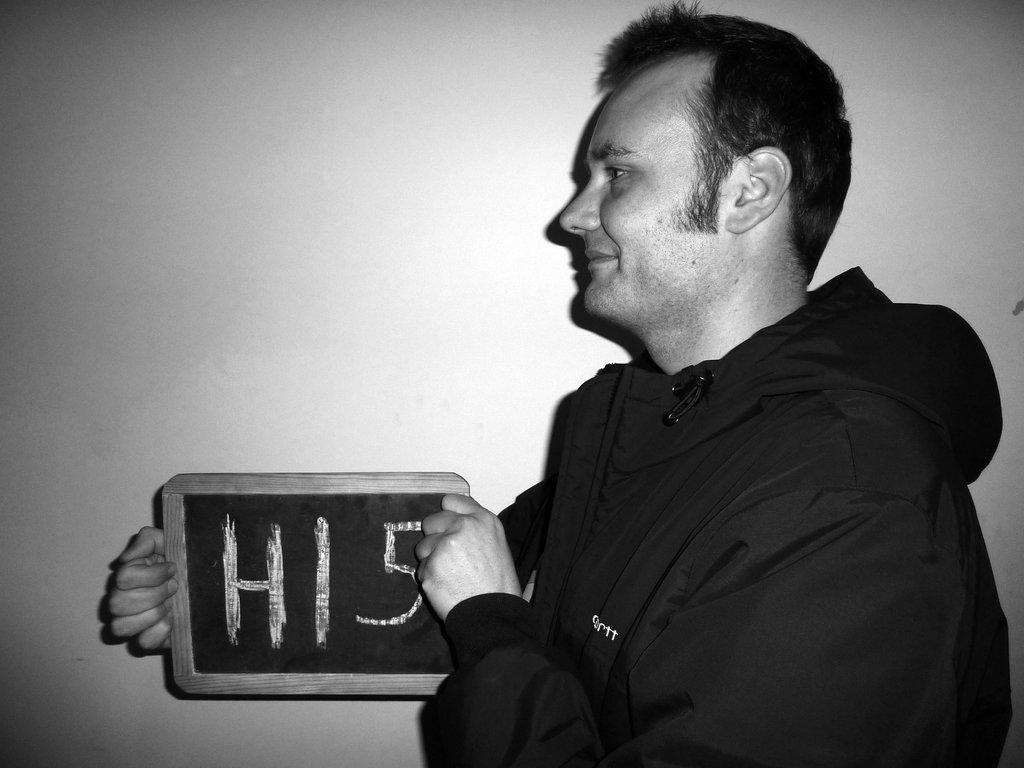Who or what is the main subject in the image? There is a person in the image. How is the person depicted in terms of color? The person is black and white. What is the person wearing? The person is wearing a black shirt. What object is the person holding? The person is holding a board. What can be read on the board? There is text on the board. How much money is the person holding in the image? There is no money visible in the image; the person is holding a board with text on it. What type of verse can be seen on the board in the image? There is no verse present on the board in the image; it contains text, but not a verse. 